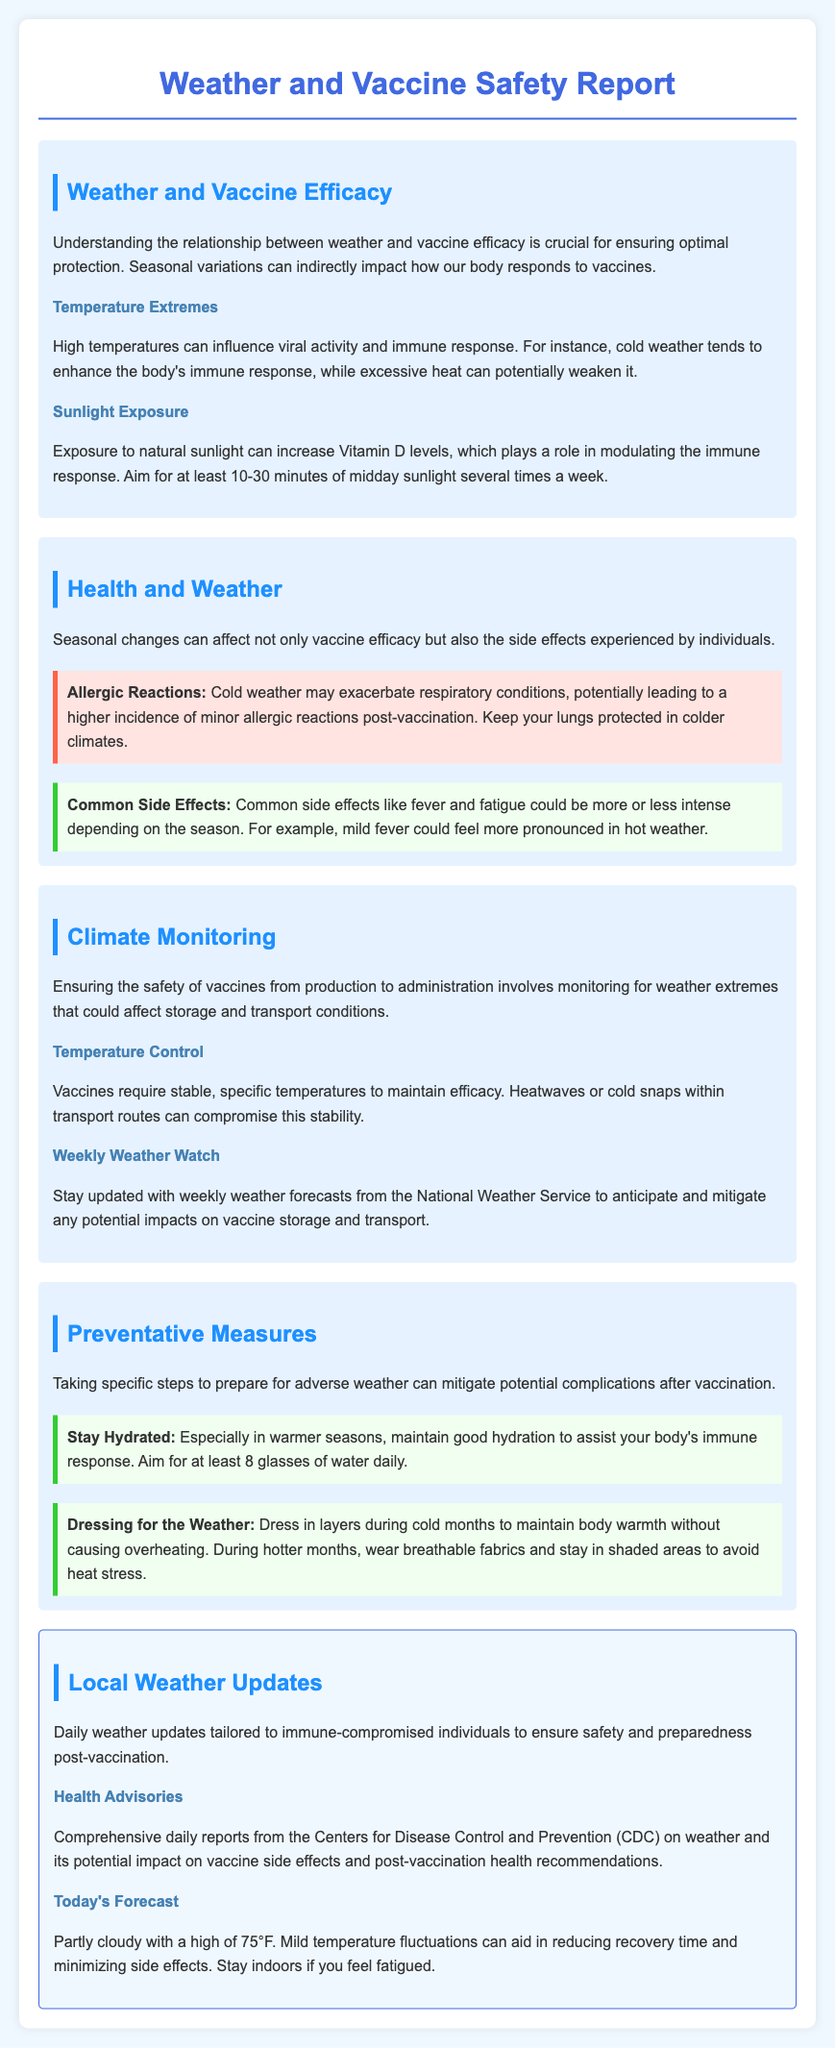What is the title of the report? The title of the report is stated at the top of the document.
Answer: Weather and Vaccine Safety Report What seasonal factor can enhance immune response? This factor is mentioned in relation to how temperature affects the body.
Answer: Cold weather What is the recommended daily sunlight exposure? This recommendation is provided to increase Vitamin D levels for immune modulation.
Answer: 10-30 minutes What type of weather may exacerbate respiratory conditions? This is mentioned in the context of allergic reactions during certain seasons.
Answer: Cold weather What should individuals aim for in terms of hydration after vaccination? This advice helps support the immune response following vaccination.
Answer: 8 glasses of water daily What is today's forecast described as? The forecast provides information about current weather conditions.
Answer: Partly cloudy What can heatwaves impact regarding vaccines? This aspect is addressed in the section about climate monitoring and vaccine safety.
Answer: Stability What precautions are suggested for dressing in cold months? This recommendation aims to maintain body warmth without overheating.
Answer: Dress in layers What is the main source for comprehensive daily weather reports mentioned? This entity provides guidelines for health and weather impacts post-vaccination.
Answer: Centers for Disease Control and Prevention (CDC) 